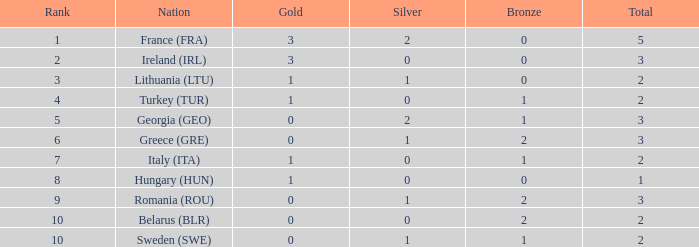What's the sum when the gold is below 0 and silver is under 1? None. 